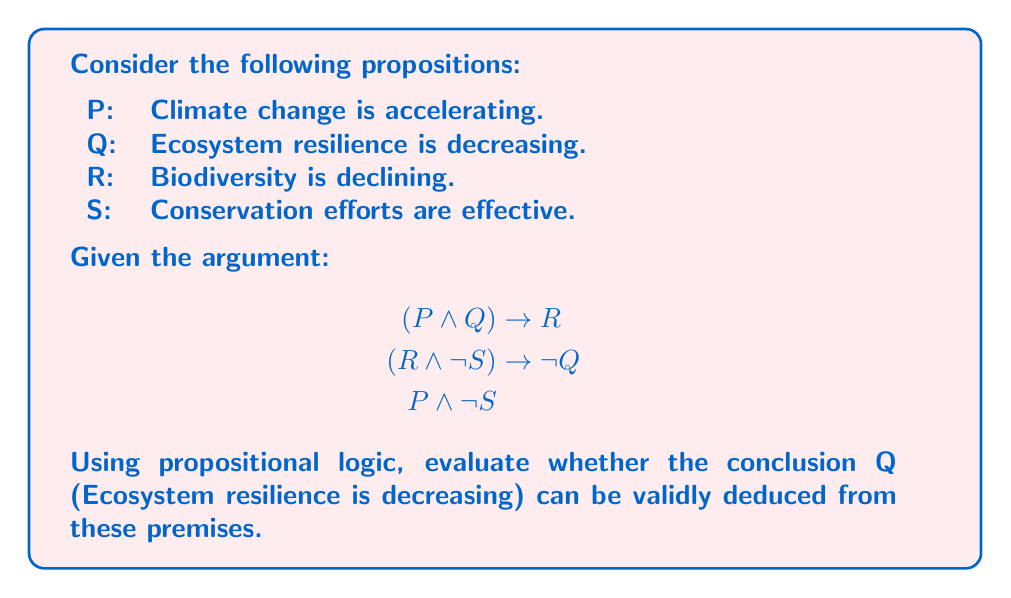What is the answer to this math problem? Let's approach this step-by-step using propositional logic:

1) First, we'll list our premises:
   Premise 1: $(P \land Q) \to R$
   Premise 2: $(R \land \lnot S) \to \lnot Q$
   Premise 3: $P \land \lnot S$

2) Our goal is to determine if Q can be validly deduced from these premises.

3) From Premise 3 ($P \land \lnot S$), we know that P is true and S is false.

4) However, we don't have direct information about Q or R from Premise 3.

5) Let's consider Premise 1: $(P \land Q) \to R$
   This tells us that if P and Q are both true, then R must be true.
   But we only know P is true, not Q, so we can't deduce R from this premise.

6) Now, let's look at Premise 2: $(R \land \lnot S) \to \lnot Q$
   This tells us that if R is true and S is false, then Q must be false.
   We know S is false from Premise 3, but we don't know if R is true.

7) At this point, we've exhausted the information given in the premises, and we haven't been able to deduce Q or $\lnot Q$.

8) In propositional logic, for a conclusion to be valid, it must necessarily follow from the premises. If there's any possibility for the conclusion to be false while the premises are true, the argument is not valid.

9) In this case, we can construct a scenario where all premises are true, but Q could be either true or false:
   - P is true, S is false (satisfying Premise 3)
   - Q is true (hypothetically)
   - R is true (satisfying Premise 1)
   This scenario doesn't violate Premise 2 because $R \land \lnot S$ is true, but $\lnot Q$ is false.

10) We can also construct a scenario where Q is false, and all premises are still satisfied.

Therefore, Q cannot be validly deduced from the given premises using propositional logic.
Answer: The conclusion Q (Ecosystem resilience is decreasing) cannot be validly deduced from the given premises using propositional logic. 